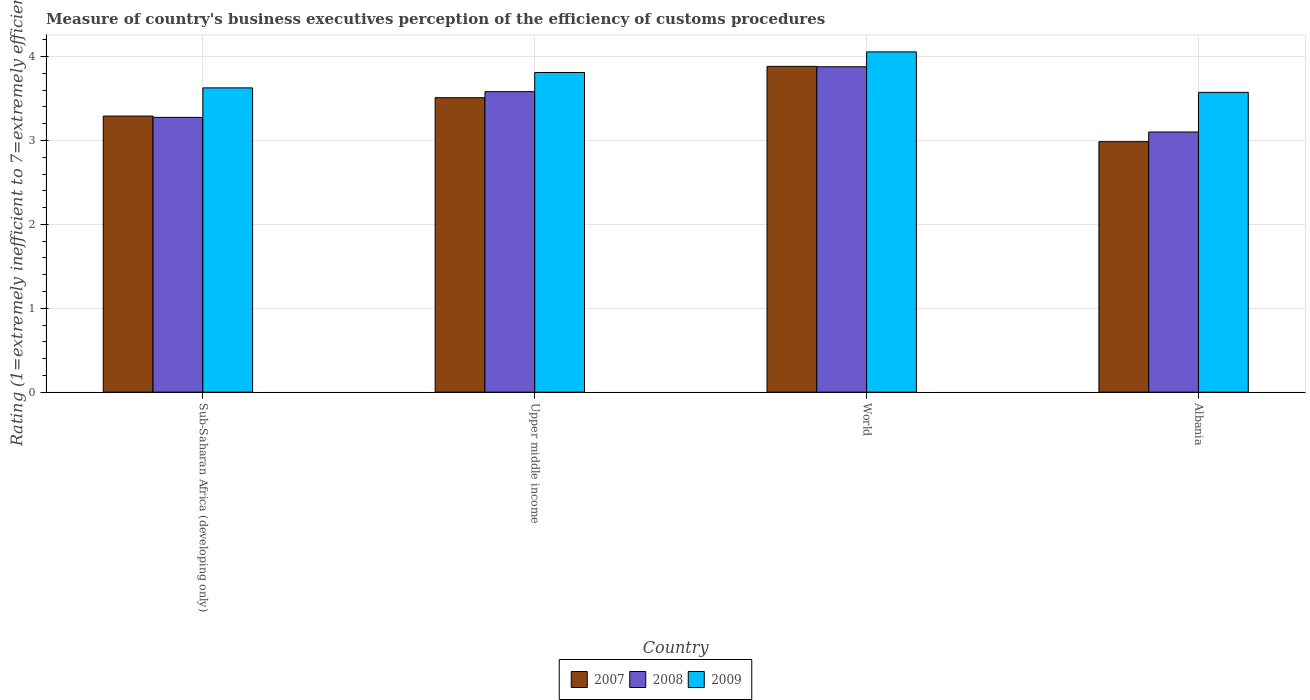Are the number of bars on each tick of the X-axis equal?
Give a very brief answer. Yes. How many bars are there on the 1st tick from the left?
Offer a terse response. 3. How many bars are there on the 4th tick from the right?
Give a very brief answer. 3. What is the label of the 1st group of bars from the left?
Offer a terse response. Sub-Saharan Africa (developing only). In how many cases, is the number of bars for a given country not equal to the number of legend labels?
Your answer should be very brief. 0. What is the rating of the efficiency of customs procedure in 2009 in Upper middle income?
Provide a short and direct response. 3.81. Across all countries, what is the maximum rating of the efficiency of customs procedure in 2008?
Your response must be concise. 3.88. Across all countries, what is the minimum rating of the efficiency of customs procedure in 2008?
Offer a terse response. 3.1. In which country was the rating of the efficiency of customs procedure in 2008 maximum?
Provide a succinct answer. World. In which country was the rating of the efficiency of customs procedure in 2007 minimum?
Your response must be concise. Albania. What is the total rating of the efficiency of customs procedure in 2009 in the graph?
Provide a short and direct response. 15.06. What is the difference between the rating of the efficiency of customs procedure in 2007 in Albania and that in Sub-Saharan Africa (developing only)?
Make the answer very short. -0.31. What is the difference between the rating of the efficiency of customs procedure in 2008 in Sub-Saharan Africa (developing only) and the rating of the efficiency of customs procedure in 2007 in Upper middle income?
Keep it short and to the point. -0.23. What is the average rating of the efficiency of customs procedure in 2007 per country?
Offer a very short reply. 3.42. What is the difference between the rating of the efficiency of customs procedure of/in 2009 and rating of the efficiency of customs procedure of/in 2007 in Upper middle income?
Provide a short and direct response. 0.3. What is the ratio of the rating of the efficiency of customs procedure in 2009 in Albania to that in World?
Provide a succinct answer. 0.88. What is the difference between the highest and the second highest rating of the efficiency of customs procedure in 2009?
Give a very brief answer. -0.18. What is the difference between the highest and the lowest rating of the efficiency of customs procedure in 2008?
Your answer should be very brief. 0.78. What does the 1st bar from the left in World represents?
Give a very brief answer. 2007. What does the 2nd bar from the right in Upper middle income represents?
Your answer should be compact. 2008. Are all the bars in the graph horizontal?
Provide a short and direct response. No. How many countries are there in the graph?
Your answer should be compact. 4. Does the graph contain grids?
Offer a very short reply. Yes. Where does the legend appear in the graph?
Make the answer very short. Bottom center. How are the legend labels stacked?
Ensure brevity in your answer.  Horizontal. What is the title of the graph?
Make the answer very short. Measure of country's business executives perception of the efficiency of customs procedures. Does "2002" appear as one of the legend labels in the graph?
Your answer should be very brief. No. What is the label or title of the Y-axis?
Ensure brevity in your answer.  Rating (1=extremely inefficient to 7=extremely efficient). What is the Rating (1=extremely inefficient to 7=extremely efficient) in 2007 in Sub-Saharan Africa (developing only)?
Offer a terse response. 3.29. What is the Rating (1=extremely inefficient to 7=extremely efficient) in 2008 in Sub-Saharan Africa (developing only)?
Offer a very short reply. 3.27. What is the Rating (1=extremely inefficient to 7=extremely efficient) in 2009 in Sub-Saharan Africa (developing only)?
Offer a terse response. 3.63. What is the Rating (1=extremely inefficient to 7=extremely efficient) in 2007 in Upper middle income?
Keep it short and to the point. 3.51. What is the Rating (1=extremely inefficient to 7=extremely efficient) of 2008 in Upper middle income?
Offer a very short reply. 3.58. What is the Rating (1=extremely inefficient to 7=extremely efficient) of 2009 in Upper middle income?
Provide a succinct answer. 3.81. What is the Rating (1=extremely inefficient to 7=extremely efficient) of 2007 in World?
Offer a terse response. 3.88. What is the Rating (1=extremely inefficient to 7=extremely efficient) of 2008 in World?
Offer a very short reply. 3.88. What is the Rating (1=extremely inefficient to 7=extremely efficient) of 2009 in World?
Offer a terse response. 4.06. What is the Rating (1=extremely inefficient to 7=extremely efficient) of 2007 in Albania?
Your answer should be compact. 2.99. What is the Rating (1=extremely inefficient to 7=extremely efficient) of 2008 in Albania?
Keep it short and to the point. 3.1. What is the Rating (1=extremely inefficient to 7=extremely efficient) in 2009 in Albania?
Provide a succinct answer. 3.57. Across all countries, what is the maximum Rating (1=extremely inefficient to 7=extremely efficient) of 2007?
Provide a short and direct response. 3.88. Across all countries, what is the maximum Rating (1=extremely inefficient to 7=extremely efficient) in 2008?
Offer a very short reply. 3.88. Across all countries, what is the maximum Rating (1=extremely inefficient to 7=extremely efficient) of 2009?
Give a very brief answer. 4.06. Across all countries, what is the minimum Rating (1=extremely inefficient to 7=extremely efficient) of 2007?
Ensure brevity in your answer.  2.99. Across all countries, what is the minimum Rating (1=extremely inefficient to 7=extremely efficient) of 2008?
Offer a very short reply. 3.1. Across all countries, what is the minimum Rating (1=extremely inefficient to 7=extremely efficient) of 2009?
Keep it short and to the point. 3.57. What is the total Rating (1=extremely inefficient to 7=extremely efficient) of 2007 in the graph?
Offer a terse response. 13.67. What is the total Rating (1=extremely inefficient to 7=extremely efficient) of 2008 in the graph?
Your answer should be very brief. 13.84. What is the total Rating (1=extremely inefficient to 7=extremely efficient) of 2009 in the graph?
Make the answer very short. 15.06. What is the difference between the Rating (1=extremely inefficient to 7=extremely efficient) in 2007 in Sub-Saharan Africa (developing only) and that in Upper middle income?
Your answer should be very brief. -0.22. What is the difference between the Rating (1=extremely inefficient to 7=extremely efficient) in 2008 in Sub-Saharan Africa (developing only) and that in Upper middle income?
Your answer should be compact. -0.31. What is the difference between the Rating (1=extremely inefficient to 7=extremely efficient) in 2009 in Sub-Saharan Africa (developing only) and that in Upper middle income?
Ensure brevity in your answer.  -0.18. What is the difference between the Rating (1=extremely inefficient to 7=extremely efficient) of 2007 in Sub-Saharan Africa (developing only) and that in World?
Your answer should be very brief. -0.59. What is the difference between the Rating (1=extremely inefficient to 7=extremely efficient) of 2008 in Sub-Saharan Africa (developing only) and that in World?
Your answer should be compact. -0.6. What is the difference between the Rating (1=extremely inefficient to 7=extremely efficient) in 2009 in Sub-Saharan Africa (developing only) and that in World?
Offer a very short reply. -0.43. What is the difference between the Rating (1=extremely inefficient to 7=extremely efficient) in 2007 in Sub-Saharan Africa (developing only) and that in Albania?
Provide a succinct answer. 0.31. What is the difference between the Rating (1=extremely inefficient to 7=extremely efficient) of 2008 in Sub-Saharan Africa (developing only) and that in Albania?
Offer a very short reply. 0.17. What is the difference between the Rating (1=extremely inefficient to 7=extremely efficient) in 2009 in Sub-Saharan Africa (developing only) and that in Albania?
Make the answer very short. 0.05. What is the difference between the Rating (1=extremely inefficient to 7=extremely efficient) in 2007 in Upper middle income and that in World?
Make the answer very short. -0.37. What is the difference between the Rating (1=extremely inefficient to 7=extremely efficient) in 2008 in Upper middle income and that in World?
Your answer should be very brief. -0.3. What is the difference between the Rating (1=extremely inefficient to 7=extremely efficient) in 2009 in Upper middle income and that in World?
Your answer should be very brief. -0.25. What is the difference between the Rating (1=extremely inefficient to 7=extremely efficient) of 2007 in Upper middle income and that in Albania?
Your response must be concise. 0.52. What is the difference between the Rating (1=extremely inefficient to 7=extremely efficient) in 2008 in Upper middle income and that in Albania?
Your answer should be compact. 0.48. What is the difference between the Rating (1=extremely inefficient to 7=extremely efficient) of 2009 in Upper middle income and that in Albania?
Your response must be concise. 0.24. What is the difference between the Rating (1=extremely inefficient to 7=extremely efficient) in 2007 in World and that in Albania?
Your answer should be compact. 0.9. What is the difference between the Rating (1=extremely inefficient to 7=extremely efficient) of 2008 in World and that in Albania?
Provide a short and direct response. 0.78. What is the difference between the Rating (1=extremely inefficient to 7=extremely efficient) of 2009 in World and that in Albania?
Your answer should be very brief. 0.48. What is the difference between the Rating (1=extremely inefficient to 7=extremely efficient) of 2007 in Sub-Saharan Africa (developing only) and the Rating (1=extremely inefficient to 7=extremely efficient) of 2008 in Upper middle income?
Make the answer very short. -0.29. What is the difference between the Rating (1=extremely inefficient to 7=extremely efficient) in 2007 in Sub-Saharan Africa (developing only) and the Rating (1=extremely inefficient to 7=extremely efficient) in 2009 in Upper middle income?
Your answer should be very brief. -0.52. What is the difference between the Rating (1=extremely inefficient to 7=extremely efficient) of 2008 in Sub-Saharan Africa (developing only) and the Rating (1=extremely inefficient to 7=extremely efficient) of 2009 in Upper middle income?
Offer a very short reply. -0.54. What is the difference between the Rating (1=extremely inefficient to 7=extremely efficient) of 2007 in Sub-Saharan Africa (developing only) and the Rating (1=extremely inefficient to 7=extremely efficient) of 2008 in World?
Your response must be concise. -0.59. What is the difference between the Rating (1=extremely inefficient to 7=extremely efficient) in 2007 in Sub-Saharan Africa (developing only) and the Rating (1=extremely inefficient to 7=extremely efficient) in 2009 in World?
Offer a terse response. -0.76. What is the difference between the Rating (1=extremely inefficient to 7=extremely efficient) in 2008 in Sub-Saharan Africa (developing only) and the Rating (1=extremely inefficient to 7=extremely efficient) in 2009 in World?
Your response must be concise. -0.78. What is the difference between the Rating (1=extremely inefficient to 7=extremely efficient) in 2007 in Sub-Saharan Africa (developing only) and the Rating (1=extremely inefficient to 7=extremely efficient) in 2008 in Albania?
Ensure brevity in your answer.  0.19. What is the difference between the Rating (1=extremely inefficient to 7=extremely efficient) in 2007 in Sub-Saharan Africa (developing only) and the Rating (1=extremely inefficient to 7=extremely efficient) in 2009 in Albania?
Your answer should be compact. -0.28. What is the difference between the Rating (1=extremely inefficient to 7=extremely efficient) of 2008 in Sub-Saharan Africa (developing only) and the Rating (1=extremely inefficient to 7=extremely efficient) of 2009 in Albania?
Offer a terse response. -0.3. What is the difference between the Rating (1=extremely inefficient to 7=extremely efficient) of 2007 in Upper middle income and the Rating (1=extremely inefficient to 7=extremely efficient) of 2008 in World?
Provide a short and direct response. -0.37. What is the difference between the Rating (1=extremely inefficient to 7=extremely efficient) in 2007 in Upper middle income and the Rating (1=extremely inefficient to 7=extremely efficient) in 2009 in World?
Make the answer very short. -0.55. What is the difference between the Rating (1=extremely inefficient to 7=extremely efficient) of 2008 in Upper middle income and the Rating (1=extremely inefficient to 7=extremely efficient) of 2009 in World?
Keep it short and to the point. -0.47. What is the difference between the Rating (1=extremely inefficient to 7=extremely efficient) in 2007 in Upper middle income and the Rating (1=extremely inefficient to 7=extremely efficient) in 2008 in Albania?
Your response must be concise. 0.41. What is the difference between the Rating (1=extremely inefficient to 7=extremely efficient) in 2007 in Upper middle income and the Rating (1=extremely inefficient to 7=extremely efficient) in 2009 in Albania?
Offer a terse response. -0.06. What is the difference between the Rating (1=extremely inefficient to 7=extremely efficient) in 2008 in Upper middle income and the Rating (1=extremely inefficient to 7=extremely efficient) in 2009 in Albania?
Keep it short and to the point. 0.01. What is the difference between the Rating (1=extremely inefficient to 7=extremely efficient) in 2007 in World and the Rating (1=extremely inefficient to 7=extremely efficient) in 2008 in Albania?
Offer a very short reply. 0.78. What is the difference between the Rating (1=extremely inefficient to 7=extremely efficient) in 2007 in World and the Rating (1=extremely inefficient to 7=extremely efficient) in 2009 in Albania?
Give a very brief answer. 0.31. What is the difference between the Rating (1=extremely inefficient to 7=extremely efficient) of 2008 in World and the Rating (1=extremely inefficient to 7=extremely efficient) of 2009 in Albania?
Keep it short and to the point. 0.31. What is the average Rating (1=extremely inefficient to 7=extremely efficient) in 2007 per country?
Make the answer very short. 3.42. What is the average Rating (1=extremely inefficient to 7=extremely efficient) in 2008 per country?
Offer a terse response. 3.46. What is the average Rating (1=extremely inefficient to 7=extremely efficient) in 2009 per country?
Offer a very short reply. 3.77. What is the difference between the Rating (1=extremely inefficient to 7=extremely efficient) of 2007 and Rating (1=extremely inefficient to 7=extremely efficient) of 2008 in Sub-Saharan Africa (developing only)?
Your response must be concise. 0.02. What is the difference between the Rating (1=extremely inefficient to 7=extremely efficient) in 2007 and Rating (1=extremely inefficient to 7=extremely efficient) in 2009 in Sub-Saharan Africa (developing only)?
Provide a succinct answer. -0.34. What is the difference between the Rating (1=extremely inefficient to 7=extremely efficient) in 2008 and Rating (1=extremely inefficient to 7=extremely efficient) in 2009 in Sub-Saharan Africa (developing only)?
Your answer should be compact. -0.35. What is the difference between the Rating (1=extremely inefficient to 7=extremely efficient) of 2007 and Rating (1=extremely inefficient to 7=extremely efficient) of 2008 in Upper middle income?
Offer a very short reply. -0.07. What is the difference between the Rating (1=extremely inefficient to 7=extremely efficient) of 2007 and Rating (1=extremely inefficient to 7=extremely efficient) of 2009 in Upper middle income?
Ensure brevity in your answer.  -0.3. What is the difference between the Rating (1=extremely inefficient to 7=extremely efficient) in 2008 and Rating (1=extremely inefficient to 7=extremely efficient) in 2009 in Upper middle income?
Provide a succinct answer. -0.23. What is the difference between the Rating (1=extremely inefficient to 7=extremely efficient) in 2007 and Rating (1=extremely inefficient to 7=extremely efficient) in 2008 in World?
Your answer should be compact. 0. What is the difference between the Rating (1=extremely inefficient to 7=extremely efficient) in 2007 and Rating (1=extremely inefficient to 7=extremely efficient) in 2009 in World?
Give a very brief answer. -0.17. What is the difference between the Rating (1=extremely inefficient to 7=extremely efficient) of 2008 and Rating (1=extremely inefficient to 7=extremely efficient) of 2009 in World?
Give a very brief answer. -0.18. What is the difference between the Rating (1=extremely inefficient to 7=extremely efficient) of 2007 and Rating (1=extremely inefficient to 7=extremely efficient) of 2008 in Albania?
Provide a succinct answer. -0.12. What is the difference between the Rating (1=extremely inefficient to 7=extremely efficient) of 2007 and Rating (1=extremely inefficient to 7=extremely efficient) of 2009 in Albania?
Your answer should be very brief. -0.59. What is the difference between the Rating (1=extremely inefficient to 7=extremely efficient) of 2008 and Rating (1=extremely inefficient to 7=extremely efficient) of 2009 in Albania?
Your answer should be very brief. -0.47. What is the ratio of the Rating (1=extremely inefficient to 7=extremely efficient) in 2007 in Sub-Saharan Africa (developing only) to that in Upper middle income?
Offer a very short reply. 0.94. What is the ratio of the Rating (1=extremely inefficient to 7=extremely efficient) of 2008 in Sub-Saharan Africa (developing only) to that in Upper middle income?
Make the answer very short. 0.91. What is the ratio of the Rating (1=extremely inefficient to 7=extremely efficient) of 2009 in Sub-Saharan Africa (developing only) to that in Upper middle income?
Offer a very short reply. 0.95. What is the ratio of the Rating (1=extremely inefficient to 7=extremely efficient) of 2007 in Sub-Saharan Africa (developing only) to that in World?
Provide a succinct answer. 0.85. What is the ratio of the Rating (1=extremely inefficient to 7=extremely efficient) of 2008 in Sub-Saharan Africa (developing only) to that in World?
Ensure brevity in your answer.  0.84. What is the ratio of the Rating (1=extremely inefficient to 7=extremely efficient) in 2009 in Sub-Saharan Africa (developing only) to that in World?
Provide a succinct answer. 0.89. What is the ratio of the Rating (1=extremely inefficient to 7=extremely efficient) in 2007 in Sub-Saharan Africa (developing only) to that in Albania?
Give a very brief answer. 1.1. What is the ratio of the Rating (1=extremely inefficient to 7=extremely efficient) of 2008 in Sub-Saharan Africa (developing only) to that in Albania?
Provide a succinct answer. 1.06. What is the ratio of the Rating (1=extremely inefficient to 7=extremely efficient) of 2009 in Sub-Saharan Africa (developing only) to that in Albania?
Offer a terse response. 1.01. What is the ratio of the Rating (1=extremely inefficient to 7=extremely efficient) of 2007 in Upper middle income to that in World?
Your answer should be very brief. 0.9. What is the ratio of the Rating (1=extremely inefficient to 7=extremely efficient) in 2008 in Upper middle income to that in World?
Provide a succinct answer. 0.92. What is the ratio of the Rating (1=extremely inefficient to 7=extremely efficient) of 2009 in Upper middle income to that in World?
Give a very brief answer. 0.94. What is the ratio of the Rating (1=extremely inefficient to 7=extremely efficient) in 2007 in Upper middle income to that in Albania?
Give a very brief answer. 1.18. What is the ratio of the Rating (1=extremely inefficient to 7=extremely efficient) in 2008 in Upper middle income to that in Albania?
Your response must be concise. 1.16. What is the ratio of the Rating (1=extremely inefficient to 7=extremely efficient) in 2009 in Upper middle income to that in Albania?
Keep it short and to the point. 1.07. What is the ratio of the Rating (1=extremely inefficient to 7=extremely efficient) in 2007 in World to that in Albania?
Offer a terse response. 1.3. What is the ratio of the Rating (1=extremely inefficient to 7=extremely efficient) in 2008 in World to that in Albania?
Give a very brief answer. 1.25. What is the ratio of the Rating (1=extremely inefficient to 7=extremely efficient) of 2009 in World to that in Albania?
Keep it short and to the point. 1.14. What is the difference between the highest and the second highest Rating (1=extremely inefficient to 7=extremely efficient) of 2007?
Make the answer very short. 0.37. What is the difference between the highest and the second highest Rating (1=extremely inefficient to 7=extremely efficient) of 2008?
Provide a succinct answer. 0.3. What is the difference between the highest and the second highest Rating (1=extremely inefficient to 7=extremely efficient) in 2009?
Give a very brief answer. 0.25. What is the difference between the highest and the lowest Rating (1=extremely inefficient to 7=extremely efficient) of 2007?
Ensure brevity in your answer.  0.9. What is the difference between the highest and the lowest Rating (1=extremely inefficient to 7=extremely efficient) in 2008?
Make the answer very short. 0.78. What is the difference between the highest and the lowest Rating (1=extremely inefficient to 7=extremely efficient) of 2009?
Give a very brief answer. 0.48. 